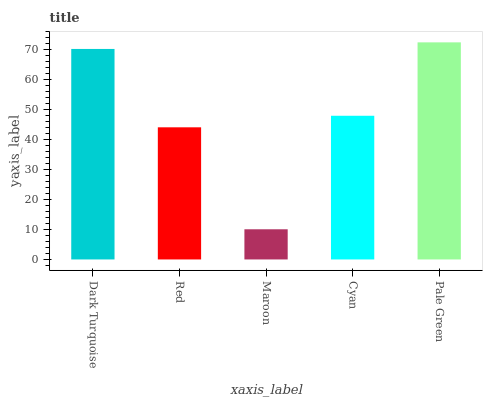Is Maroon the minimum?
Answer yes or no. Yes. Is Pale Green the maximum?
Answer yes or no. Yes. Is Red the minimum?
Answer yes or no. No. Is Red the maximum?
Answer yes or no. No. Is Dark Turquoise greater than Red?
Answer yes or no. Yes. Is Red less than Dark Turquoise?
Answer yes or no. Yes. Is Red greater than Dark Turquoise?
Answer yes or no. No. Is Dark Turquoise less than Red?
Answer yes or no. No. Is Cyan the high median?
Answer yes or no. Yes. Is Cyan the low median?
Answer yes or no. Yes. Is Dark Turquoise the high median?
Answer yes or no. No. Is Dark Turquoise the low median?
Answer yes or no. No. 